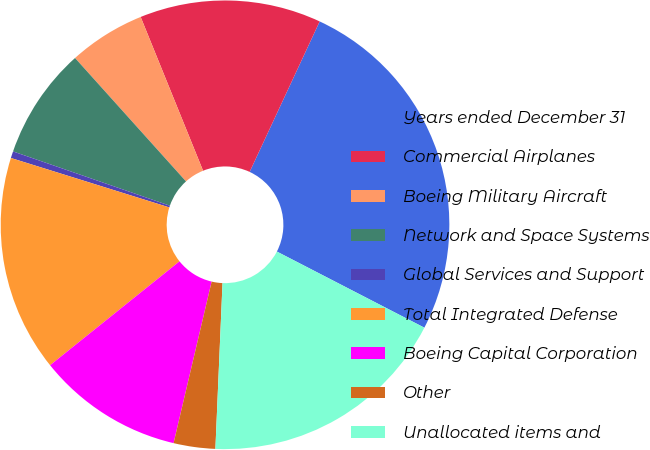Convert chart. <chart><loc_0><loc_0><loc_500><loc_500><pie_chart><fcel>Years ended December 31<fcel>Commercial Airplanes<fcel>Boeing Military Aircraft<fcel>Network and Space Systems<fcel>Global Services and Support<fcel>Total Integrated Defense<fcel>Boeing Capital Corporation<fcel>Other<fcel>Unallocated items and<nl><fcel>25.65%<fcel>13.07%<fcel>5.52%<fcel>8.04%<fcel>0.49%<fcel>15.58%<fcel>10.55%<fcel>3.0%<fcel>18.1%<nl></chart> 